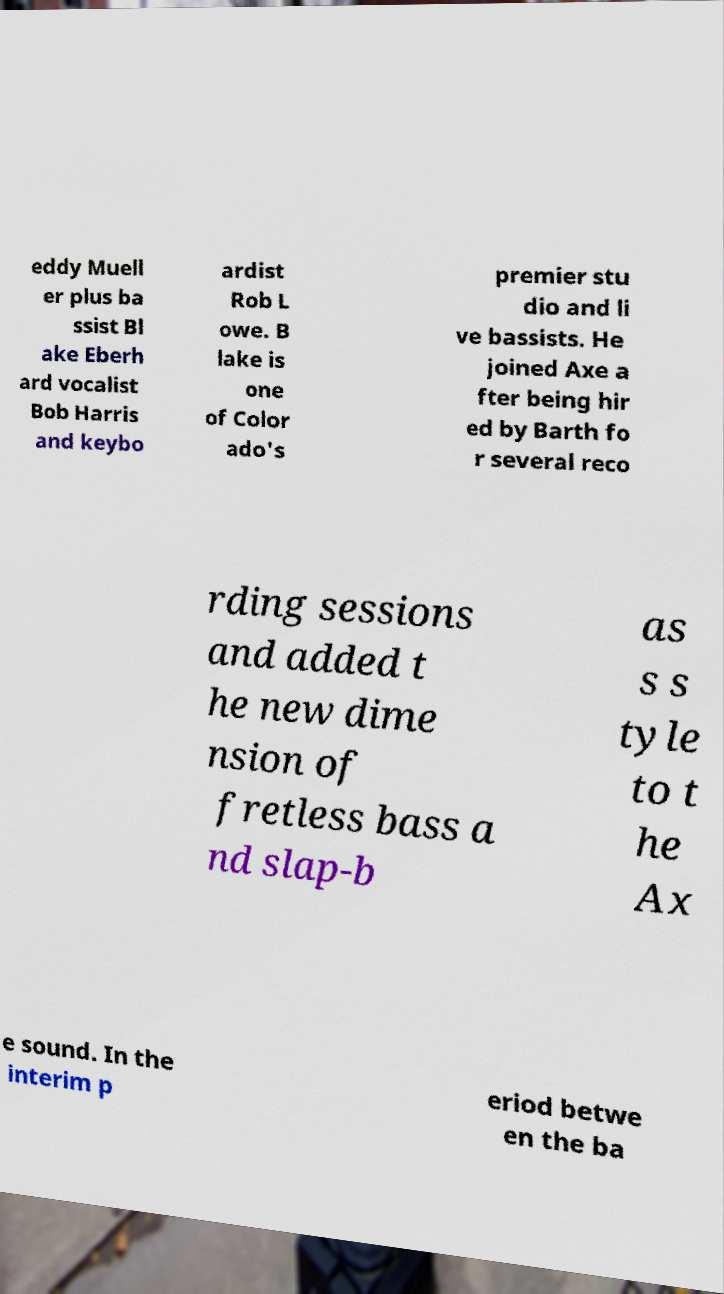I need the written content from this picture converted into text. Can you do that? eddy Muell er plus ba ssist Bl ake Eberh ard vocalist Bob Harris and keybo ardist Rob L owe. B lake is one of Color ado's premier stu dio and li ve bassists. He joined Axe a fter being hir ed by Barth fo r several reco rding sessions and added t he new dime nsion of fretless bass a nd slap-b as s s tyle to t he Ax e sound. In the interim p eriod betwe en the ba 